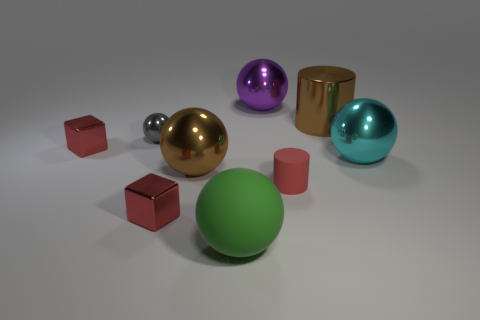Subtract all purple balls. How many balls are left? 4 Add 1 large gray balls. How many objects exist? 10 Subtract 1 cylinders. How many cylinders are left? 1 Subtract all red cylinders. How many cylinders are left? 1 Subtract all cylinders. How many objects are left? 7 Add 6 large matte objects. How many large matte objects are left? 7 Add 1 red rubber cylinders. How many red rubber cylinders exist? 2 Subtract 0 cyan cylinders. How many objects are left? 9 Subtract all red balls. Subtract all purple cubes. How many balls are left? 5 Subtract all cyan objects. Subtract all metal objects. How many objects are left? 1 